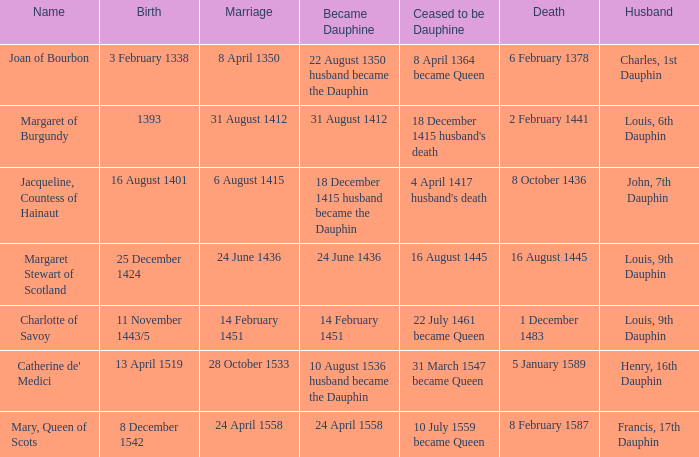When was the marriage when became dauphine is 31 august 1412? 31 August 1412. 